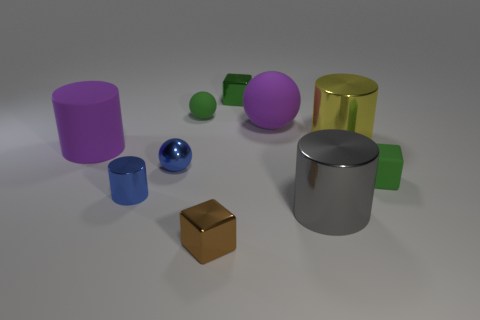Subtract all brown cubes. How many cubes are left? 2 Subtract all tiny spheres. How many spheres are left? 1 Add 3 purple balls. How many purple balls exist? 4 Subtract 0 cyan blocks. How many objects are left? 10 Subtract all cylinders. How many objects are left? 6 Subtract 2 cylinders. How many cylinders are left? 2 Subtract all purple cylinders. Subtract all cyan blocks. How many cylinders are left? 3 Subtract all brown cylinders. How many green spheres are left? 1 Subtract all purple rubber blocks. Subtract all small green matte cubes. How many objects are left? 9 Add 8 brown shiny objects. How many brown shiny objects are left? 9 